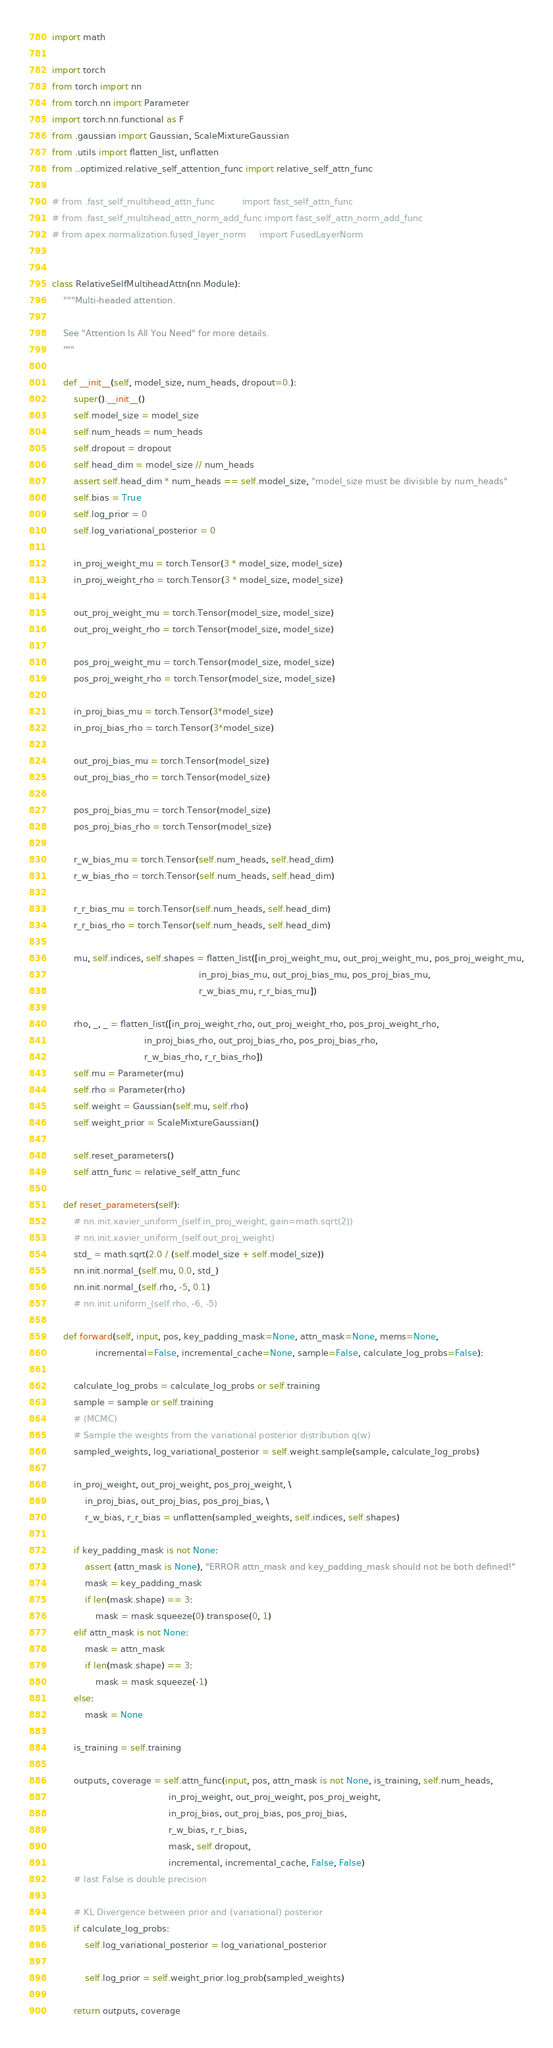Convert code to text. <code><loc_0><loc_0><loc_500><loc_500><_Python_>import math

import torch
from torch import nn
from torch.nn import Parameter
import torch.nn.functional as F
from .gaussian import Gaussian, ScaleMixtureGaussian
from .utils import flatten_list, unflatten
from ..optimized.relative_self_attention_func import relative_self_attn_func

# from .fast_self_multihead_attn_func          import fast_self_attn_func
# from .fast_self_multihead_attn_norm_add_func import fast_self_attn_norm_add_func
# from apex.normalization.fused_layer_norm     import FusedLayerNorm


class RelativeSelfMultiheadAttn(nn.Module):
    """Multi-headed attention.

    See "Attention Is All You Need" for more details.
    """

    def __init__(self, model_size, num_heads, dropout=0.):
        super().__init__()
        self.model_size = model_size
        self.num_heads = num_heads
        self.dropout = dropout
        self.head_dim = model_size // num_heads
        assert self.head_dim * num_heads == self.model_size, "model_size must be divisible by num_heads"
        self.bias = True
        self.log_prior = 0
        self.log_variational_posterior = 0

        in_proj_weight_mu = torch.Tensor(3 * model_size, model_size)
        in_proj_weight_rho = torch.Tensor(3 * model_size, model_size)

        out_proj_weight_mu = torch.Tensor(model_size, model_size)
        out_proj_weight_rho = torch.Tensor(model_size, model_size)

        pos_proj_weight_mu = torch.Tensor(model_size, model_size)
        pos_proj_weight_rho = torch.Tensor(model_size, model_size)

        in_proj_bias_mu = torch.Tensor(3*model_size)
        in_proj_bias_rho = torch.Tensor(3*model_size)

        out_proj_bias_mu = torch.Tensor(model_size)
        out_proj_bias_rho = torch.Tensor(model_size)

        pos_proj_bias_mu = torch.Tensor(model_size)
        pos_proj_bias_rho = torch.Tensor(model_size)

        r_w_bias_mu = torch.Tensor(self.num_heads, self.head_dim)
        r_w_bias_rho = torch.Tensor(self.num_heads, self.head_dim)

        r_r_bias_mu = torch.Tensor(self.num_heads, self.head_dim)
        r_r_bias_rho = torch.Tensor(self.num_heads, self.head_dim)

        mu, self.indices, self.shapes = flatten_list([in_proj_weight_mu, out_proj_weight_mu, pos_proj_weight_mu,
                                                      in_proj_bias_mu, out_proj_bias_mu, pos_proj_bias_mu,
                                                      r_w_bias_mu, r_r_bias_mu])

        rho, _, _ = flatten_list([in_proj_weight_rho, out_proj_weight_rho, pos_proj_weight_rho,
                                  in_proj_bias_rho, out_proj_bias_rho, pos_proj_bias_rho,
                                  r_w_bias_rho, r_r_bias_rho])
        self.mu = Parameter(mu)
        self.rho = Parameter(rho)
        self.weight = Gaussian(self.mu, self.rho)
        self.weight_prior = ScaleMixtureGaussian()

        self.reset_parameters()
        self.attn_func = relative_self_attn_func

    def reset_parameters(self):
        # nn.init.xavier_uniform_(self.in_proj_weight, gain=math.sqrt(2))
        # nn.init.xavier_uniform_(self.out_proj_weight)
        std_ = math.sqrt(2.0 / (self.model_size + self.model_size))
        nn.init.normal_(self.mu, 0.0, std_)
        nn.init.normal_(self.rho, -5, 0.1)
        # nn.init.uniform_(self.rho, -6, -5)

    def forward(self, input, pos, key_padding_mask=None, attn_mask=None, mems=None,
                incremental=False, incremental_cache=None, sample=False, calculate_log_probs=False):

        calculate_log_probs = calculate_log_probs or self.training
        sample = sample or self.training
        # (MCMC)
        # Sample the weights from the variational posterior distribution q(w)
        sampled_weights, log_variational_posterior = self.weight.sample(sample, calculate_log_probs)

        in_proj_weight, out_proj_weight, pos_proj_weight, \
            in_proj_bias, out_proj_bias, pos_proj_bias, \
            r_w_bias, r_r_bias = unflatten(sampled_weights, self.indices, self.shapes)

        if key_padding_mask is not None:
            assert (attn_mask is None), "ERROR attn_mask and key_padding_mask should not be both defined!"
            mask = key_padding_mask
            if len(mask.shape) == 3:
                mask = mask.squeeze(0).transpose(0, 1)
        elif attn_mask is not None:
            mask = attn_mask
            if len(mask.shape) == 3:
                mask = mask.squeeze(-1)
        else:
            mask = None

        is_training = self.training

        outputs, coverage = self.attn_func(input, pos, attn_mask is not None, is_training, self.num_heads,
                                           in_proj_weight, out_proj_weight, pos_proj_weight,
                                           in_proj_bias, out_proj_bias, pos_proj_bias,
                                           r_w_bias, r_r_bias,
                                           mask, self.dropout,
                                           incremental, incremental_cache, False, False)
        # last False is double precision

        # KL Divergence between prior and (variational) posterior
        if calculate_log_probs:
            self.log_variational_posterior = log_variational_posterior

            self.log_prior = self.weight_prior.log_prob(sampled_weights)

        return outputs, coverage
</code> 